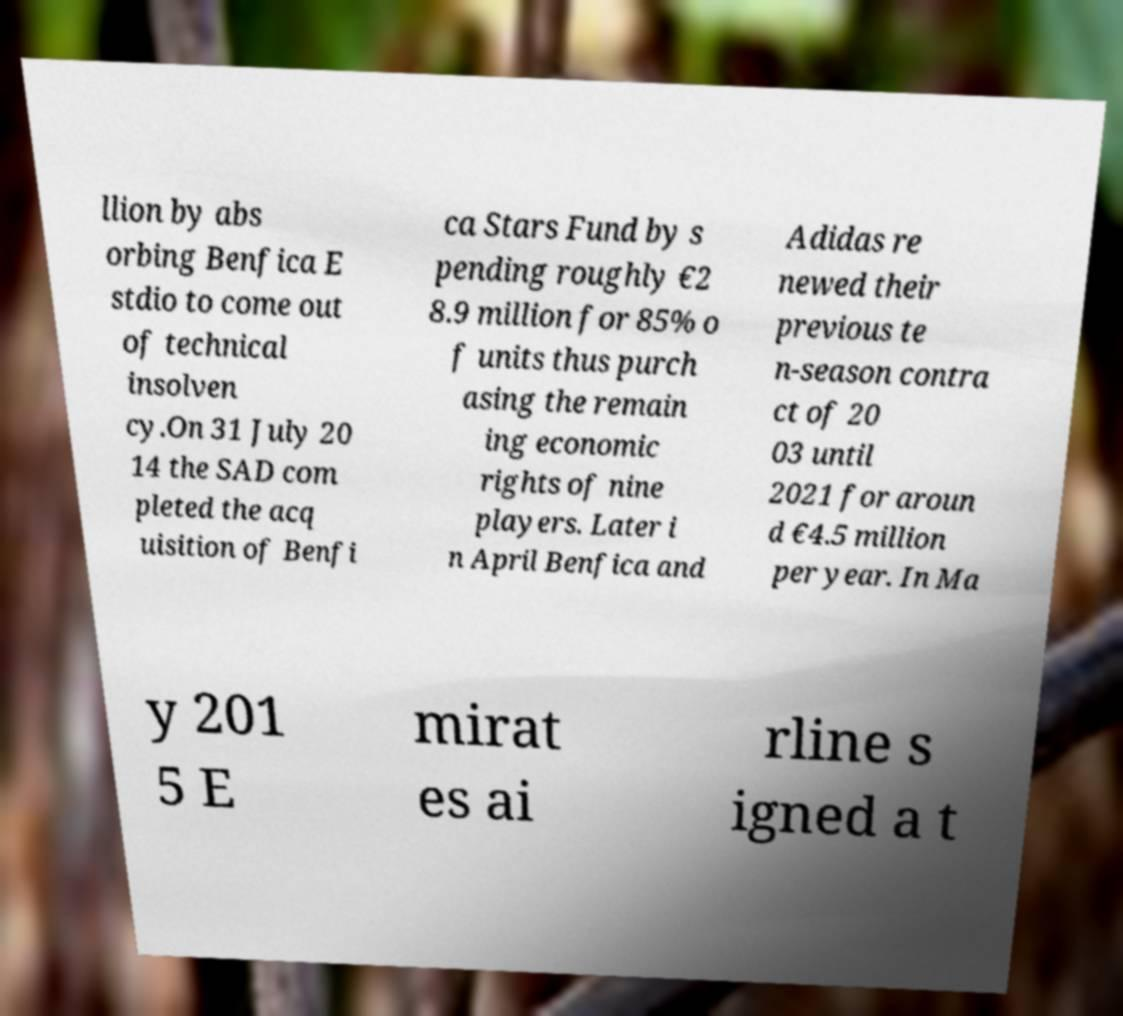Can you accurately transcribe the text from the provided image for me? llion by abs orbing Benfica E stdio to come out of technical insolven cy.On 31 July 20 14 the SAD com pleted the acq uisition of Benfi ca Stars Fund by s pending roughly €2 8.9 million for 85% o f units thus purch asing the remain ing economic rights of nine players. Later i n April Benfica and Adidas re newed their previous te n-season contra ct of 20 03 until 2021 for aroun d €4.5 million per year. In Ma y 201 5 E mirat es ai rline s igned a t 